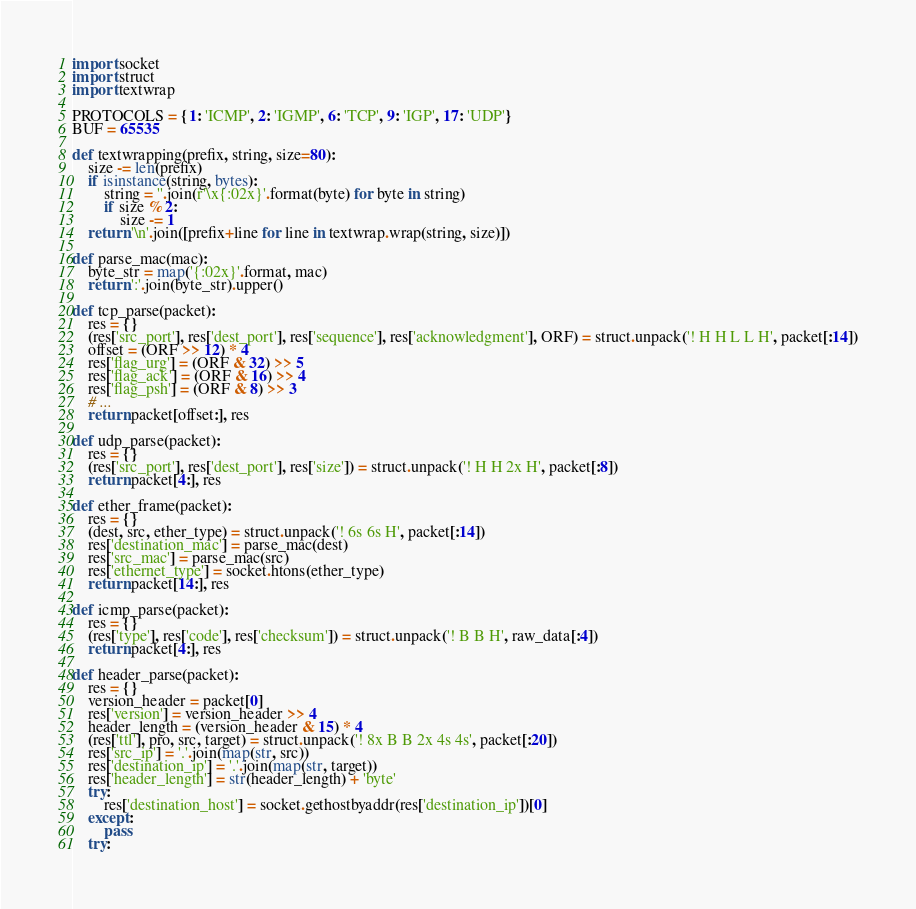Convert code to text. <code><loc_0><loc_0><loc_500><loc_500><_Python_>import socket
import struct
import textwrap

PROTOCOLS = {1: 'ICMP', 2: 'IGMP', 6: 'TCP', 9: 'IGP', 17: 'UDP'}
BUF = 65535

def textwrapping(prefix, string, size=80):
	size -= len(prefix)
	if isinstance(string, bytes):
		string = ''.join(r'\x{:02x}'.format(byte) for byte in string)
		if size % 2:
			size -= 1
	return '\n'.join([prefix+line for line in textwrap.wrap(string, size)])

def parse_mac(mac):
	byte_str = map('{:02x}'.format, mac)
	return ':'.join(byte_str).upper()

def tcp_parse(packet):
	res = {}
	(res['src_port'], res['dest_port'], res['sequence'], res['acknowledgment'], ORF) = struct.unpack('! H H L L H', packet[:14])
	offset = (ORF >> 12) * 4
	res['flag_urg'] = (ORF & 32) >> 5
	res['flag_ack'] = (ORF & 16) >> 4
	res['flag_psh'] = (ORF & 8) >> 3
	# ...
	return packet[offset:], res

def udp_parse(packet):
	res = {}
	(res['src_port'], res['dest_port'], res['size']) = struct.unpack('! H H 2x H', packet[:8])
	return packet[4:], res

def ether_frame(packet):
	res = {}
	(dest, src, ether_type) = struct.unpack('! 6s 6s H', packet[:14])
	res['destination_mac'] = parse_mac(dest)
	res['src_mac'] = parse_mac(src)
	res['ethernet_type'] = socket.htons(ether_type)
	return packet[14:], res

def icmp_parse(packet):
	res = {}
	(res['type'], res['code'], res['checksum']) = struct.unpack('! B B H', raw_data[:4])
	return packet[4:], res

def header_parse(packet):
	res = {}
	version_header = packet[0]
	res['version'] = version_header >> 4
	header_length = (version_header & 15) * 4
	(res['ttl'], pro, src, target) = struct.unpack('! 8x B B 2x 4s 4s', packet[:20])
	res['src_ip'] = '.'.join(map(str, src))
	res['destination_ip'] = '.'.join(map(str, target))
	res['header_length'] = str(header_length) + 'byte'
	try:
		res['destination_host'] = socket.gethostbyaddr(res['destination_ip'])[0]
	except:
		pass
	try:</code> 